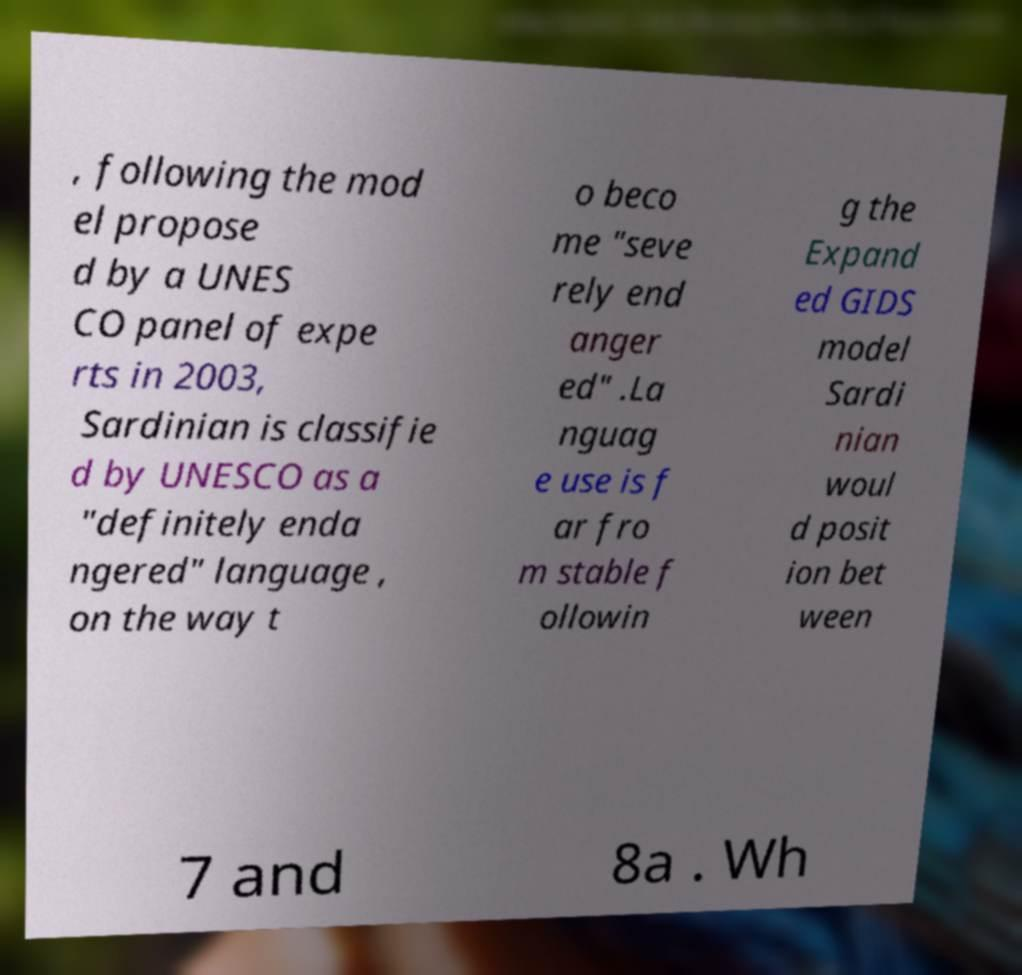Please identify and transcribe the text found in this image. , following the mod el propose d by a UNES CO panel of expe rts in 2003, Sardinian is classifie d by UNESCO as a "definitely enda ngered" language , on the way t o beco me "seve rely end anger ed" .La nguag e use is f ar fro m stable f ollowin g the Expand ed GIDS model Sardi nian woul d posit ion bet ween 7 and 8a . Wh 